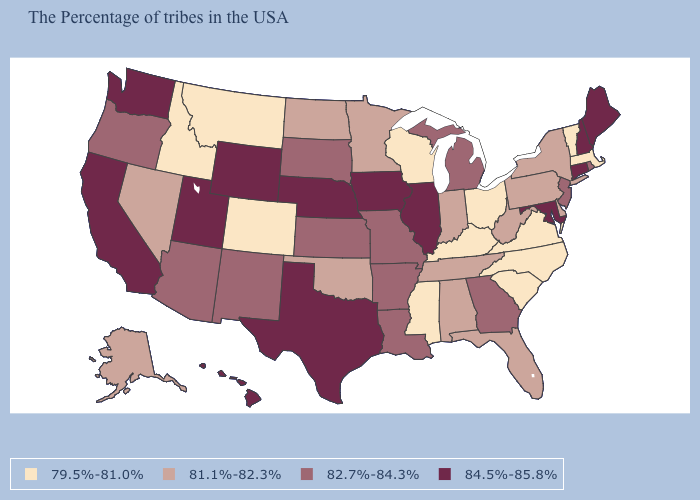Does North Dakota have the same value as Oklahoma?
Concise answer only. Yes. Name the states that have a value in the range 79.5%-81.0%?
Be succinct. Massachusetts, Vermont, Virginia, North Carolina, South Carolina, Ohio, Kentucky, Wisconsin, Mississippi, Colorado, Montana, Idaho. What is the value of Vermont?
Answer briefly. 79.5%-81.0%. Is the legend a continuous bar?
Keep it brief. No. What is the lowest value in states that border Washington?
Answer briefly. 79.5%-81.0%. Which states hav the highest value in the Northeast?
Answer briefly. Maine, New Hampshire, Connecticut. Name the states that have a value in the range 81.1%-82.3%?
Write a very short answer. New York, Delaware, Pennsylvania, West Virginia, Florida, Indiana, Alabama, Tennessee, Minnesota, Oklahoma, North Dakota, Nevada, Alaska. Among the states that border New Hampshire , which have the highest value?
Give a very brief answer. Maine. What is the highest value in the MidWest ?
Keep it brief. 84.5%-85.8%. Does Idaho have the highest value in the West?
Write a very short answer. No. Among the states that border Oregon , which have the lowest value?
Quick response, please. Idaho. Does North Dakota have the lowest value in the MidWest?
Concise answer only. No. What is the lowest value in states that border Colorado?
Give a very brief answer. 81.1%-82.3%. Name the states that have a value in the range 79.5%-81.0%?
Give a very brief answer. Massachusetts, Vermont, Virginia, North Carolina, South Carolina, Ohio, Kentucky, Wisconsin, Mississippi, Colorado, Montana, Idaho. Does Louisiana have the same value as New Jersey?
Write a very short answer. Yes. 